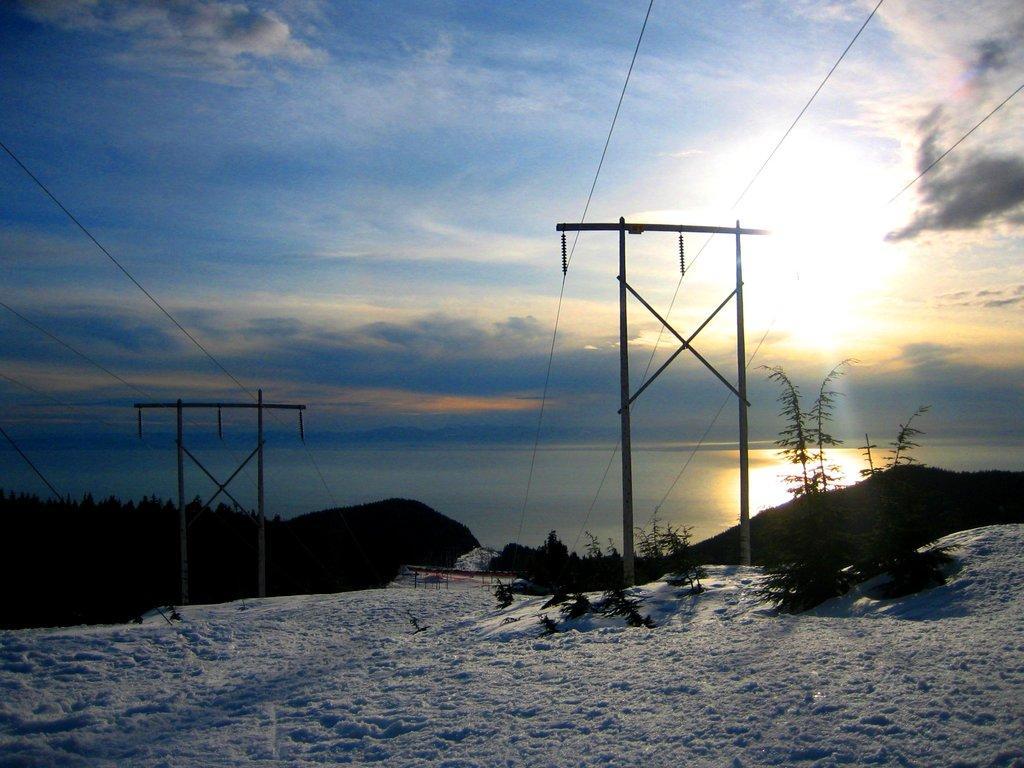How would you summarize this image in a sentence or two? In this image there are electric poles on the ground. There is snow on the ground. In the background there are mountains and trees. At the top there is the sky. 